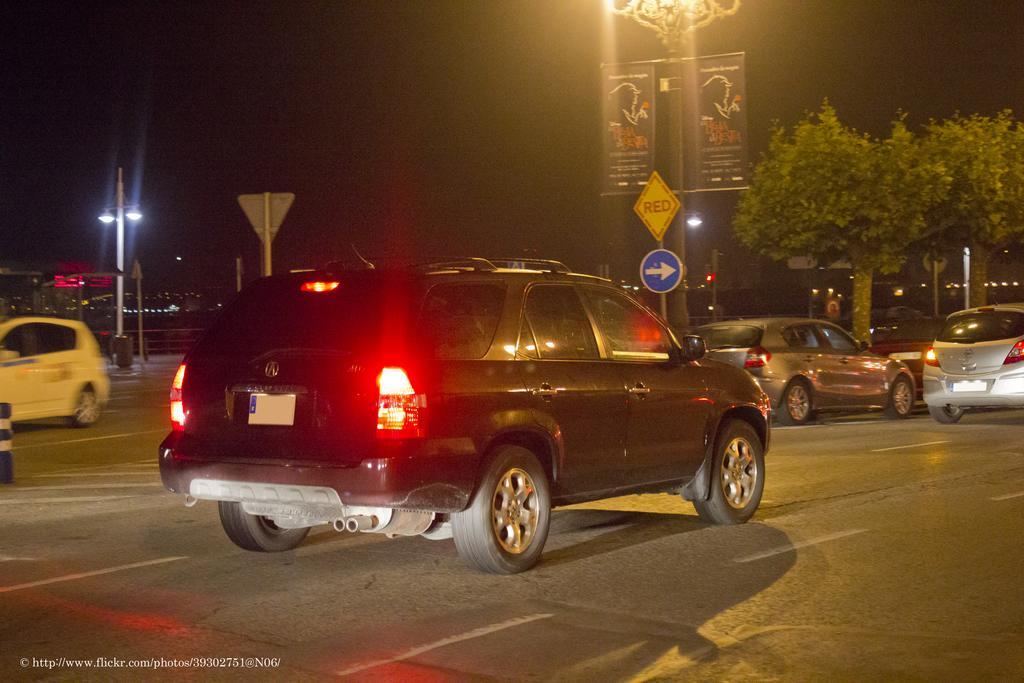Could you give a brief overview of what you see in this image? In this image we can see some group of vehicles which are moving on the road and at the background of the image there are some lights, traffic signals, signage board, wordings, trees and dark sky. 